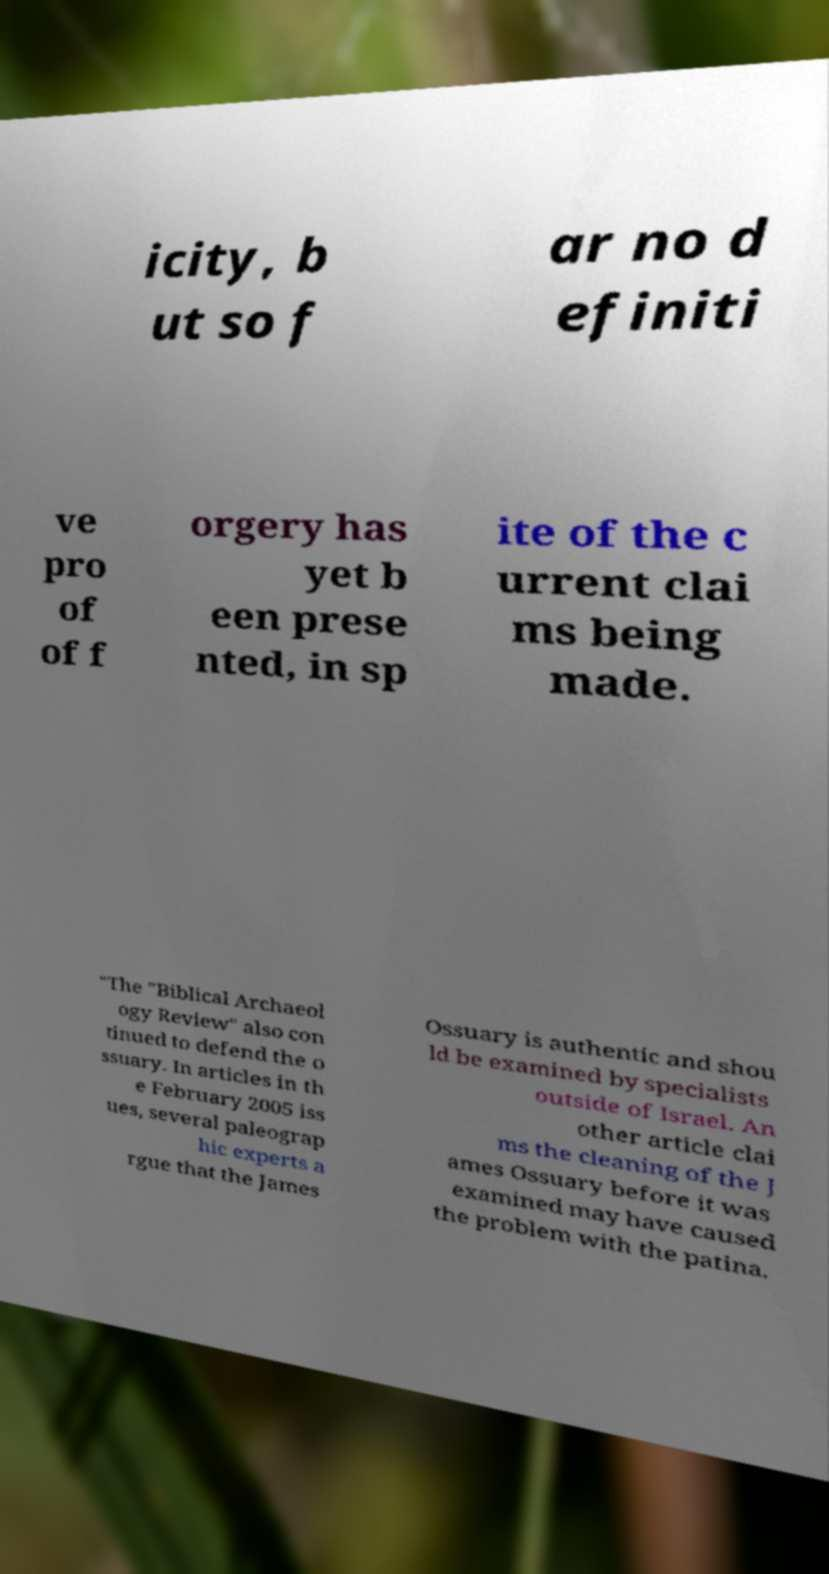Please read and relay the text visible in this image. What does it say? icity, b ut so f ar no d efiniti ve pro of of f orgery has yet b een prese nted, in sp ite of the c urrent clai ms being made. "The "Biblical Archaeol ogy Review" also con tinued to defend the o ssuary. In articles in th e February 2005 iss ues, several paleograp hic experts a rgue that the James Ossuary is authentic and shou ld be examined by specialists outside of Israel. An other article clai ms the cleaning of the J ames Ossuary before it was examined may have caused the problem with the patina. 